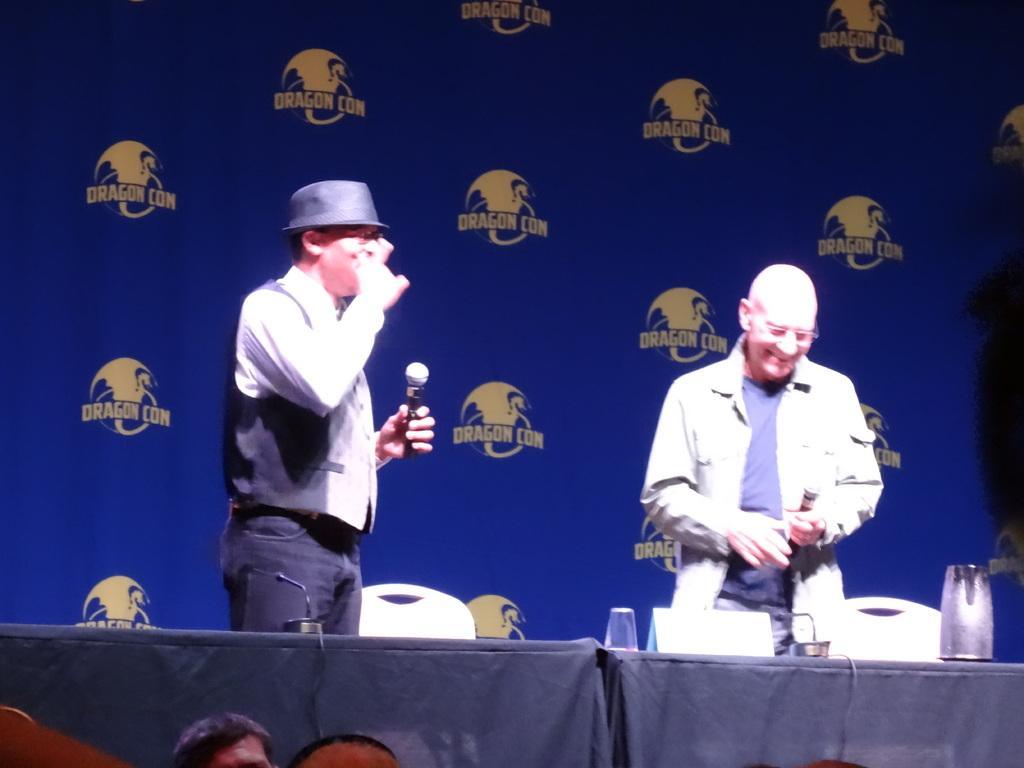Describe this image in one or two sentences. In this image I can see two men are standing and both of them are holding mics. I can also see one of them is wearing a hat and another one is wearing a specs. I can also see few chairs and few tables. on these tables I can see mics, a glass and a jar. Here I can see one more person and in the background I can see a banner. 